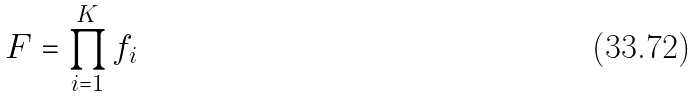Convert formula to latex. <formula><loc_0><loc_0><loc_500><loc_500>F = \prod _ { i = 1 } ^ { K } f _ { i }</formula> 